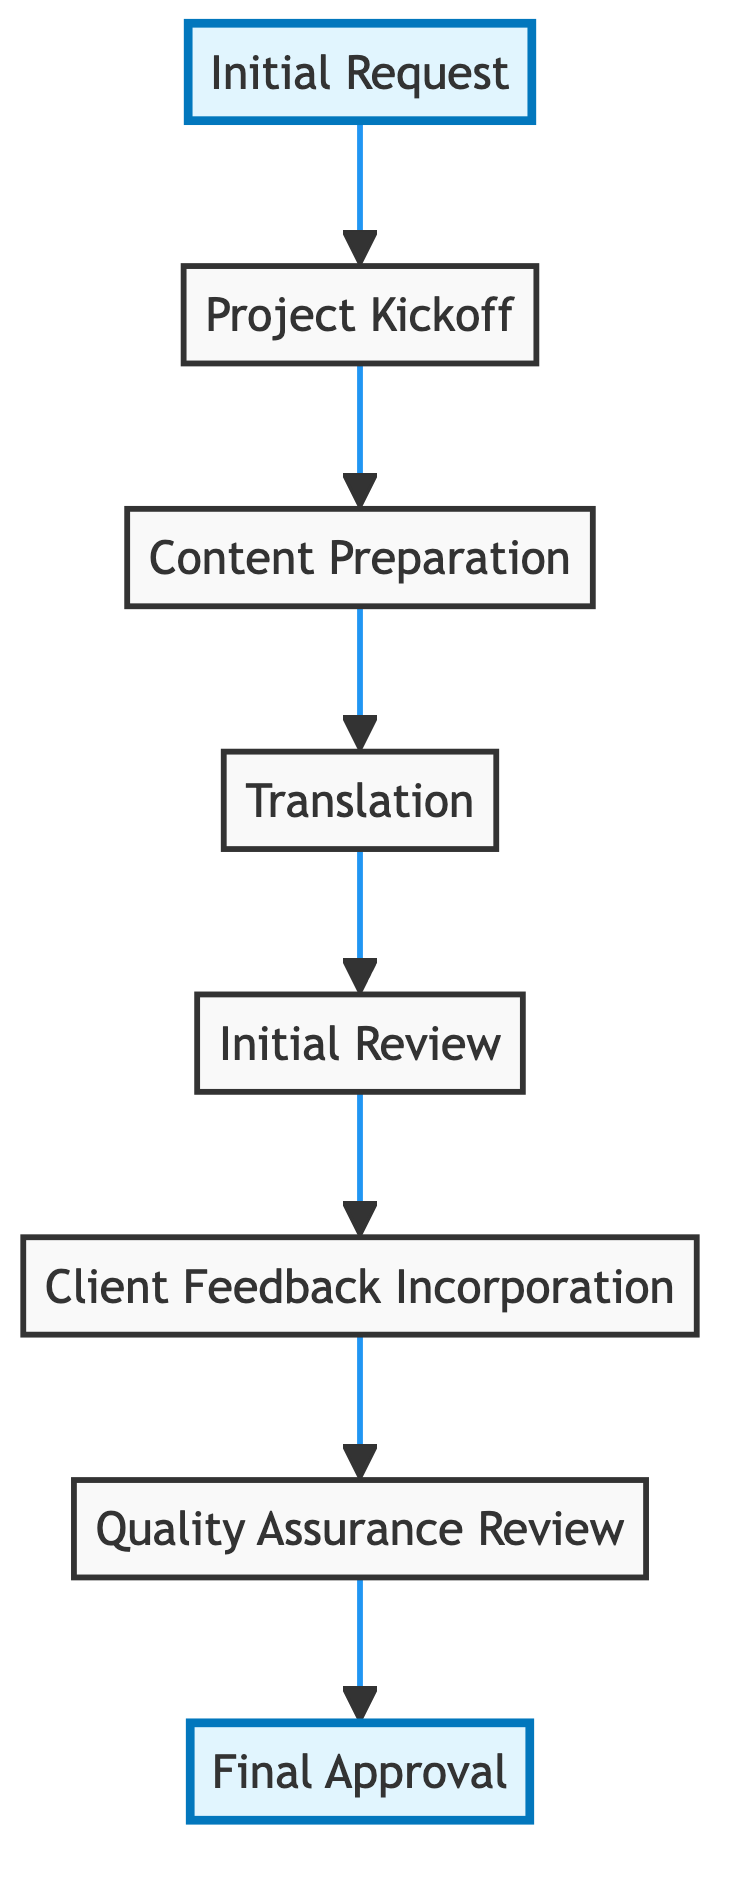What is the first step in the workflow? The first step in the workflow is "Initial Request," which signifies that the client submits a request for translation of marketing materials.
Answer: Initial Request How many total steps are there in the workflow? The workflow consists of a total of eight steps, from "Initial Request" to "Final Approval."
Answer: 8 Which step comes after "Content Preparation"? The step that comes after "Content Preparation" is "Translation," where the requested marketing materials are translated by a native speaker.
Answer: Translation What is the last step in the workflow? The last step of the workflow is "Final Approval," indicating that the client reviews the final translated marketing materials and provides approval.
Answer: Final Approval What happens in the "Client Feedback Incorporation" step? In this step, any feedback from the client on the initial draft of the translation is reviewed and incorporated into the subsequent revisions.
Answer: Review and incorporation of client feedback Which two steps are adjacent to "Quality Assurance Review"? The two steps adjacent to "Quality Assurance Review" are "Client Feedback Incorporation" (before it) and "Final Approval" (after it).
Answer: Client Feedback Incorporation and Final Approval How does the initial review relate to translation? The "Initial Review" takes place after "Translation" to check the translated materials for adherence to guidelines and overall quality before incorporating client feedback.
Answer: It occurs after Translation What is the purpose of the "Project Kickoff"? The purpose of the "Project Kickoff" is to have an initial brief and discussions between the client and the translation team to understand project requirements and brand voice.
Answer: Understand project requirements and brand voice 